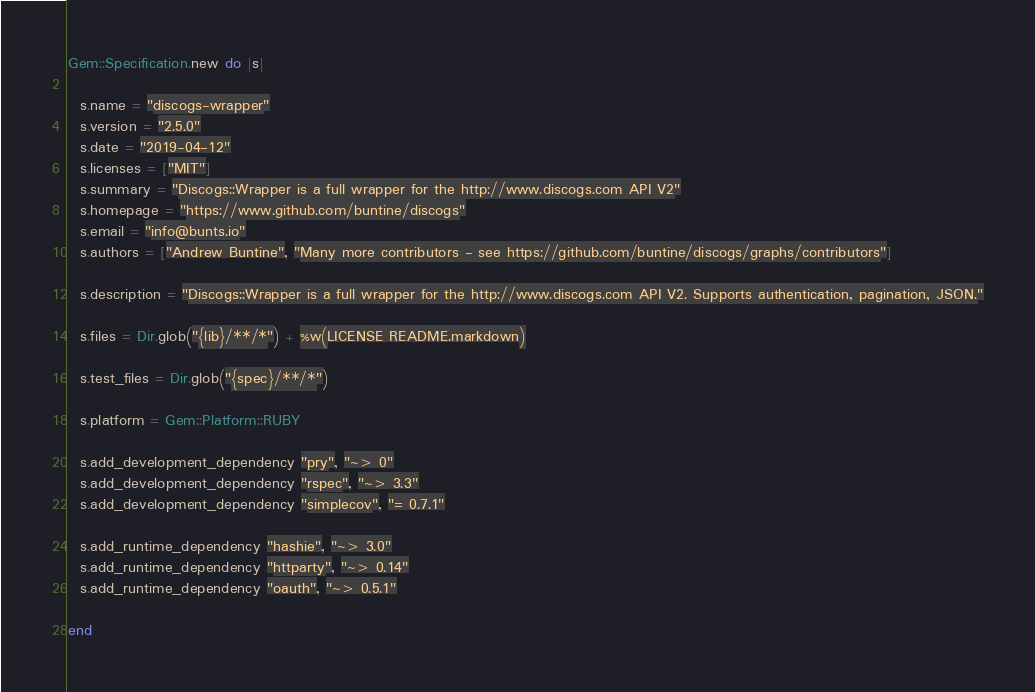Convert code to text. <code><loc_0><loc_0><loc_500><loc_500><_Ruby_>Gem::Specification.new do |s|
  
  s.name = "discogs-wrapper"
  s.version = "2.5.0"
  s.date = "2019-04-12"
  s.licenses = ["MIT"]
  s.summary = "Discogs::Wrapper is a full wrapper for the http://www.discogs.com API V2"
  s.homepage = "https://www.github.com/buntine/discogs"
  s.email = "info@bunts.io"
  s.authors = ["Andrew Buntine", "Many more contributors - see https://github.com/buntine/discogs/graphs/contributors"]
  
  s.description = "Discogs::Wrapper is a full wrapper for the http://www.discogs.com API V2. Supports authentication, pagination, JSON."
  
  s.files = Dir.glob("{lib}/**/*") + %w(LICENSE README.markdown)

  s.test_files = Dir.glob("{spec}/**/*")

  s.platform = Gem::Platform::RUBY
  
  s.add_development_dependency "pry", "~> 0"
  s.add_development_dependency "rspec", "~> 3.3"
  s.add_development_dependency "simplecov", "= 0.7.1"
  
  s.add_runtime_dependency "hashie", "~> 3.0"
  s.add_runtime_dependency "httparty", "~> 0.14"
  s.add_runtime_dependency "oauth", "~> 0.5.1"

end
</code> 